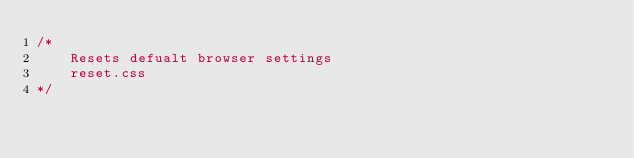Convert code to text. <code><loc_0><loc_0><loc_500><loc_500><_CSS_>/*
	Resets defualt browser settings
	reset.css
*/</code> 